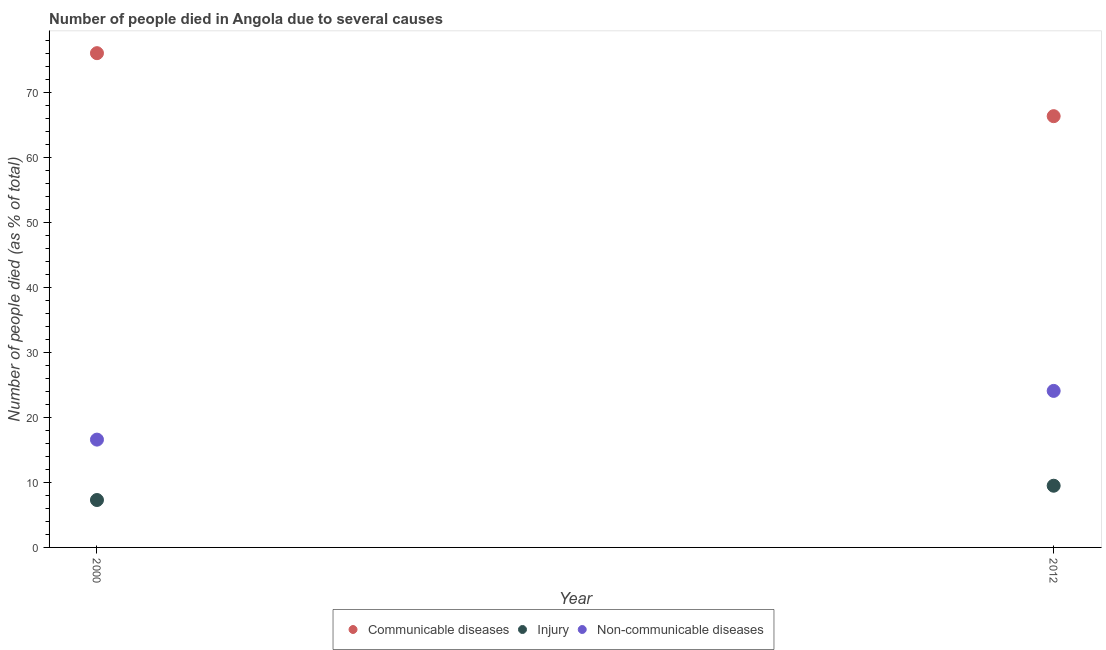How many different coloured dotlines are there?
Offer a terse response. 3. Across all years, what is the maximum number of people who died of communicable diseases?
Your answer should be compact. 76.1. Across all years, what is the minimum number of people who died of injury?
Ensure brevity in your answer.  7.3. In which year was the number of people who dies of non-communicable diseases maximum?
Your answer should be compact. 2012. In which year was the number of people who died of communicable diseases minimum?
Make the answer very short. 2012. What is the total number of people who dies of non-communicable diseases in the graph?
Your answer should be compact. 40.7. What is the difference between the number of people who dies of non-communicable diseases in 2000 and that in 2012?
Your answer should be very brief. -7.5. What is the average number of people who dies of non-communicable diseases per year?
Make the answer very short. 20.35. In the year 2000, what is the difference between the number of people who died of communicable diseases and number of people who died of injury?
Provide a succinct answer. 68.8. What is the ratio of the number of people who died of injury in 2000 to that in 2012?
Provide a succinct answer. 0.77. In how many years, is the number of people who died of injury greater than the average number of people who died of injury taken over all years?
Provide a short and direct response. 1. Is it the case that in every year, the sum of the number of people who died of communicable diseases and number of people who died of injury is greater than the number of people who dies of non-communicable diseases?
Your answer should be compact. Yes. Is the number of people who dies of non-communicable diseases strictly greater than the number of people who died of injury over the years?
Your response must be concise. Yes. Is the number of people who dies of non-communicable diseases strictly less than the number of people who died of injury over the years?
Your answer should be compact. No. How many years are there in the graph?
Make the answer very short. 2. Are the values on the major ticks of Y-axis written in scientific E-notation?
Give a very brief answer. No. Does the graph contain any zero values?
Ensure brevity in your answer.  No. How many legend labels are there?
Your response must be concise. 3. What is the title of the graph?
Your response must be concise. Number of people died in Angola due to several causes. What is the label or title of the Y-axis?
Offer a terse response. Number of people died (as % of total). What is the Number of people died (as % of total) of Communicable diseases in 2000?
Your response must be concise. 76.1. What is the Number of people died (as % of total) in Communicable diseases in 2012?
Provide a succinct answer. 66.4. What is the Number of people died (as % of total) of Injury in 2012?
Give a very brief answer. 9.5. What is the Number of people died (as % of total) of Non-communicable diseases in 2012?
Your answer should be very brief. 24.1. Across all years, what is the maximum Number of people died (as % of total) in Communicable diseases?
Your response must be concise. 76.1. Across all years, what is the maximum Number of people died (as % of total) of Non-communicable diseases?
Offer a terse response. 24.1. Across all years, what is the minimum Number of people died (as % of total) in Communicable diseases?
Your answer should be compact. 66.4. What is the total Number of people died (as % of total) of Communicable diseases in the graph?
Offer a terse response. 142.5. What is the total Number of people died (as % of total) in Non-communicable diseases in the graph?
Provide a succinct answer. 40.7. What is the difference between the Number of people died (as % of total) in Communicable diseases in 2000 and the Number of people died (as % of total) in Injury in 2012?
Provide a succinct answer. 66.6. What is the difference between the Number of people died (as % of total) in Communicable diseases in 2000 and the Number of people died (as % of total) in Non-communicable diseases in 2012?
Make the answer very short. 52. What is the difference between the Number of people died (as % of total) in Injury in 2000 and the Number of people died (as % of total) in Non-communicable diseases in 2012?
Provide a succinct answer. -16.8. What is the average Number of people died (as % of total) in Communicable diseases per year?
Your answer should be very brief. 71.25. What is the average Number of people died (as % of total) of Non-communicable diseases per year?
Offer a terse response. 20.35. In the year 2000, what is the difference between the Number of people died (as % of total) of Communicable diseases and Number of people died (as % of total) of Injury?
Keep it short and to the point. 68.8. In the year 2000, what is the difference between the Number of people died (as % of total) in Communicable diseases and Number of people died (as % of total) in Non-communicable diseases?
Provide a succinct answer. 59.5. In the year 2012, what is the difference between the Number of people died (as % of total) in Communicable diseases and Number of people died (as % of total) in Injury?
Your response must be concise. 56.9. In the year 2012, what is the difference between the Number of people died (as % of total) of Communicable diseases and Number of people died (as % of total) of Non-communicable diseases?
Ensure brevity in your answer.  42.3. In the year 2012, what is the difference between the Number of people died (as % of total) of Injury and Number of people died (as % of total) of Non-communicable diseases?
Offer a terse response. -14.6. What is the ratio of the Number of people died (as % of total) of Communicable diseases in 2000 to that in 2012?
Your answer should be compact. 1.15. What is the ratio of the Number of people died (as % of total) in Injury in 2000 to that in 2012?
Offer a very short reply. 0.77. What is the ratio of the Number of people died (as % of total) in Non-communicable diseases in 2000 to that in 2012?
Give a very brief answer. 0.69. What is the difference between the highest and the second highest Number of people died (as % of total) in Communicable diseases?
Your answer should be compact. 9.7. What is the difference between the highest and the second highest Number of people died (as % of total) of Injury?
Your response must be concise. 2.2. What is the difference between the highest and the lowest Number of people died (as % of total) of Communicable diseases?
Provide a succinct answer. 9.7. What is the difference between the highest and the lowest Number of people died (as % of total) of Injury?
Offer a terse response. 2.2. What is the difference between the highest and the lowest Number of people died (as % of total) of Non-communicable diseases?
Keep it short and to the point. 7.5. 